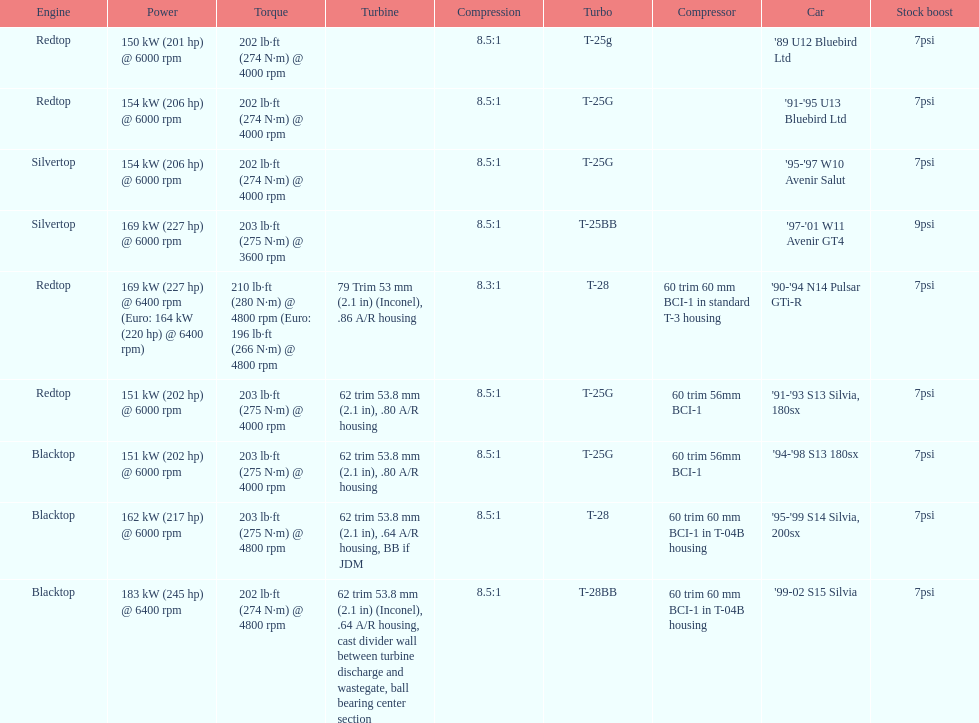Which engine has the smallest compression rate? '90-'94 N14 Pulsar GTi-R. 